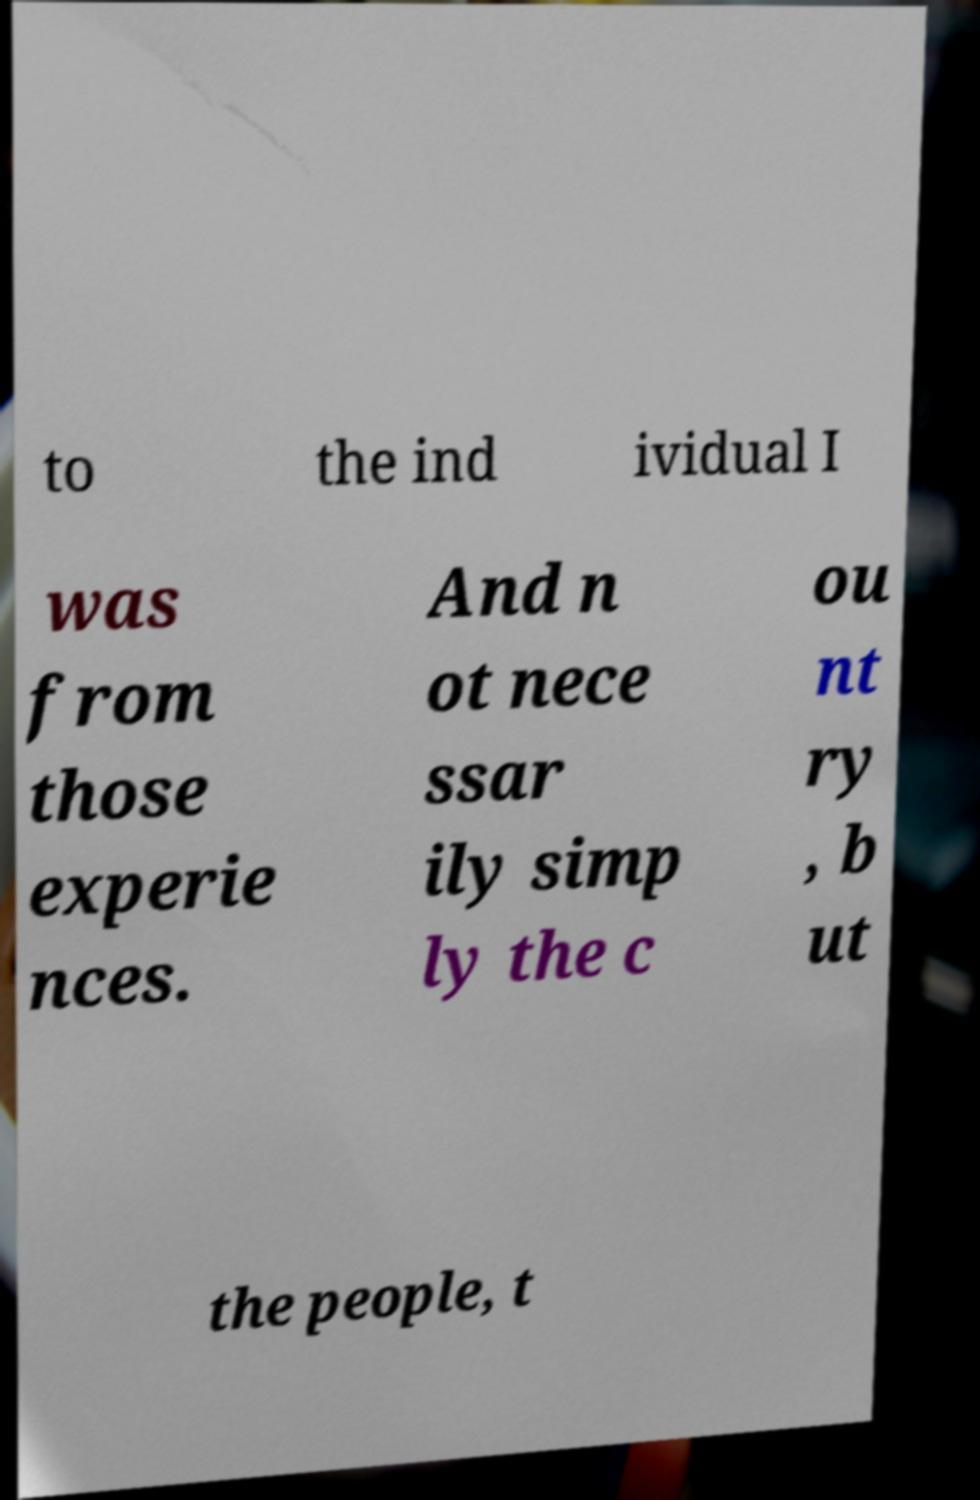I need the written content from this picture converted into text. Can you do that? to the ind ividual I was from those experie nces. And n ot nece ssar ily simp ly the c ou nt ry , b ut the people, t 